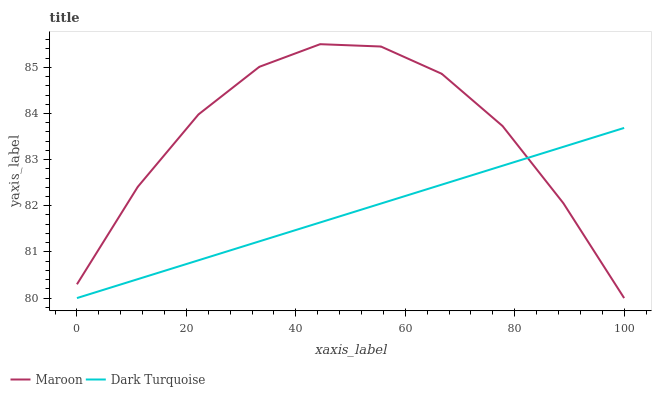Does Dark Turquoise have the minimum area under the curve?
Answer yes or no. Yes. Does Maroon have the maximum area under the curve?
Answer yes or no. Yes. Does Maroon have the minimum area under the curve?
Answer yes or no. No. Is Dark Turquoise the smoothest?
Answer yes or no. Yes. Is Maroon the roughest?
Answer yes or no. Yes. Is Maroon the smoothest?
Answer yes or no. No. Does Dark Turquoise have the lowest value?
Answer yes or no. Yes. Does Maroon have the highest value?
Answer yes or no. Yes. Does Dark Turquoise intersect Maroon?
Answer yes or no. Yes. Is Dark Turquoise less than Maroon?
Answer yes or no. No. Is Dark Turquoise greater than Maroon?
Answer yes or no. No. 